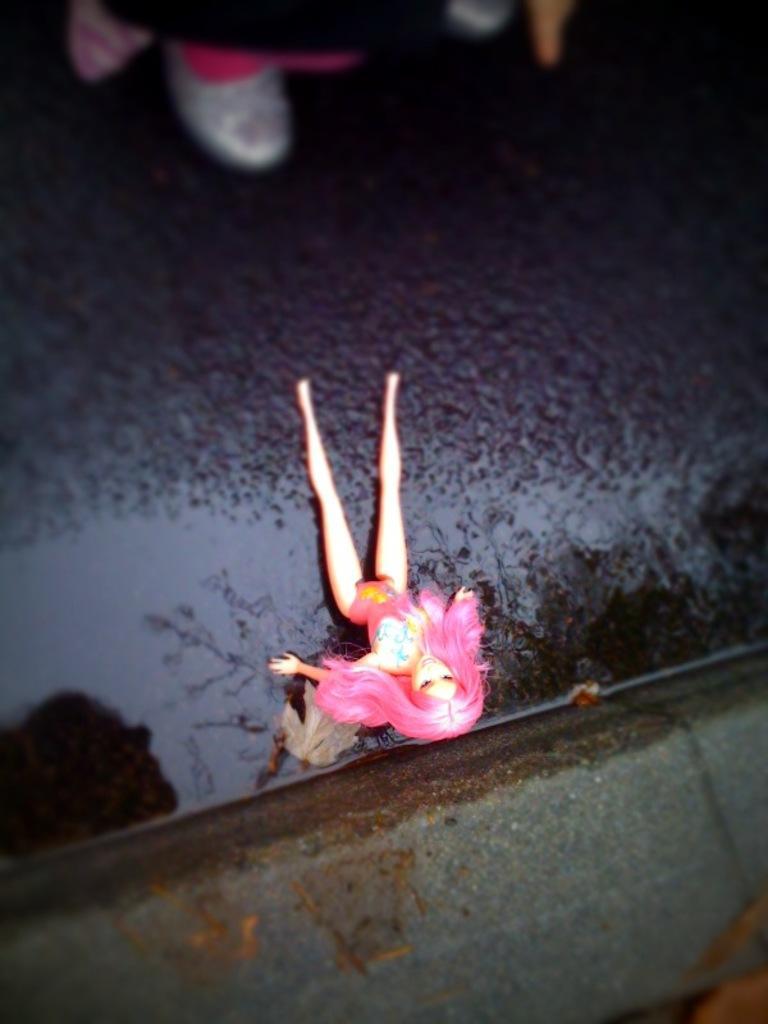Could you give a brief overview of what you see in this image? In the center of the image, we can see a doll on the road and in the background, we can see a person. 